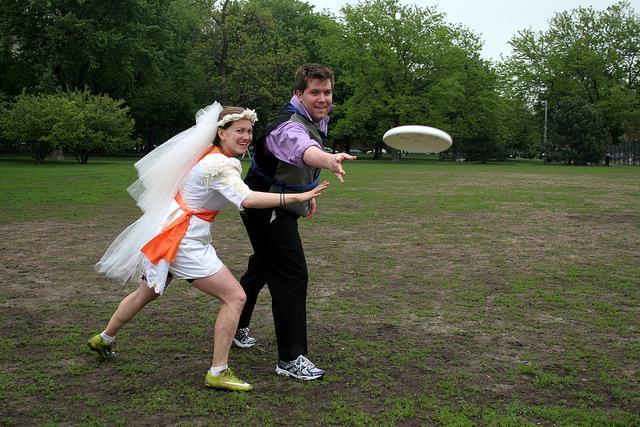How many humans are there?
Give a very brief answer. 2. How many people are in the photo?
Give a very brief answer. 2. How many people are there?
Give a very brief answer. 2. How many elephants are there?
Give a very brief answer. 0. 